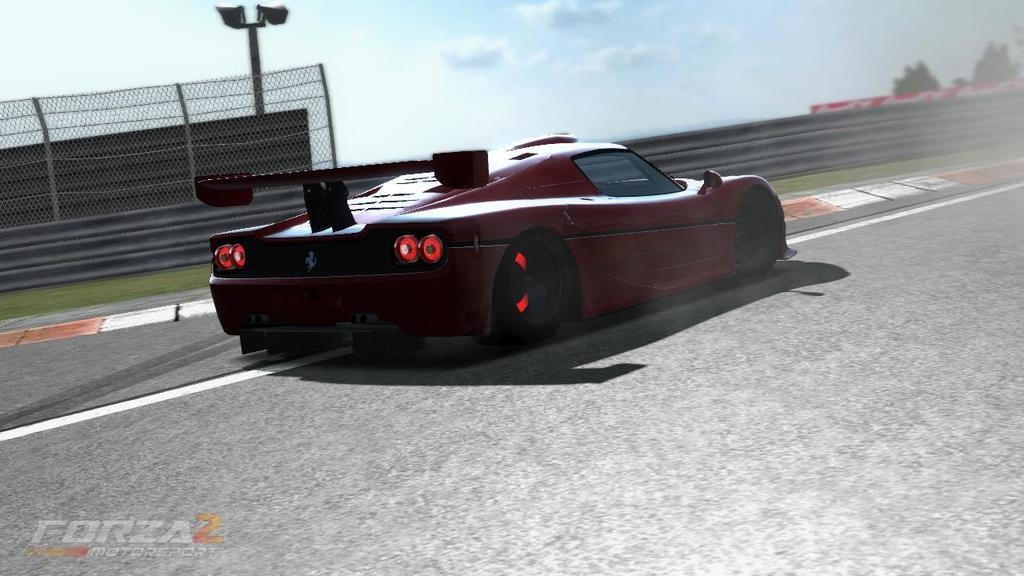What is the main subject of the image? The main subject of the image is a car on the road. What can be seen in the background of the image? In the background of the image, there is a mesh visible and clouds in the sky. What type of history can be seen in the image? There is no specific historical event or reference visible in the image; it primarily features a car on the road and a background with a mesh and clouds. 